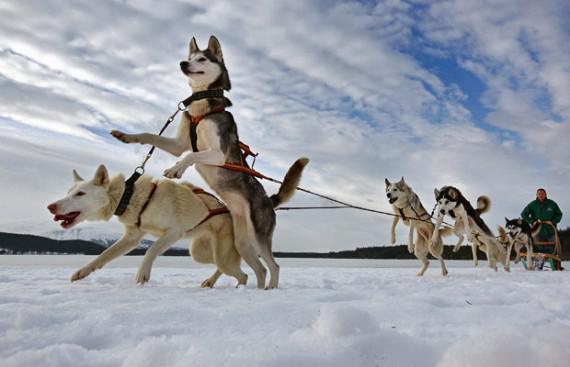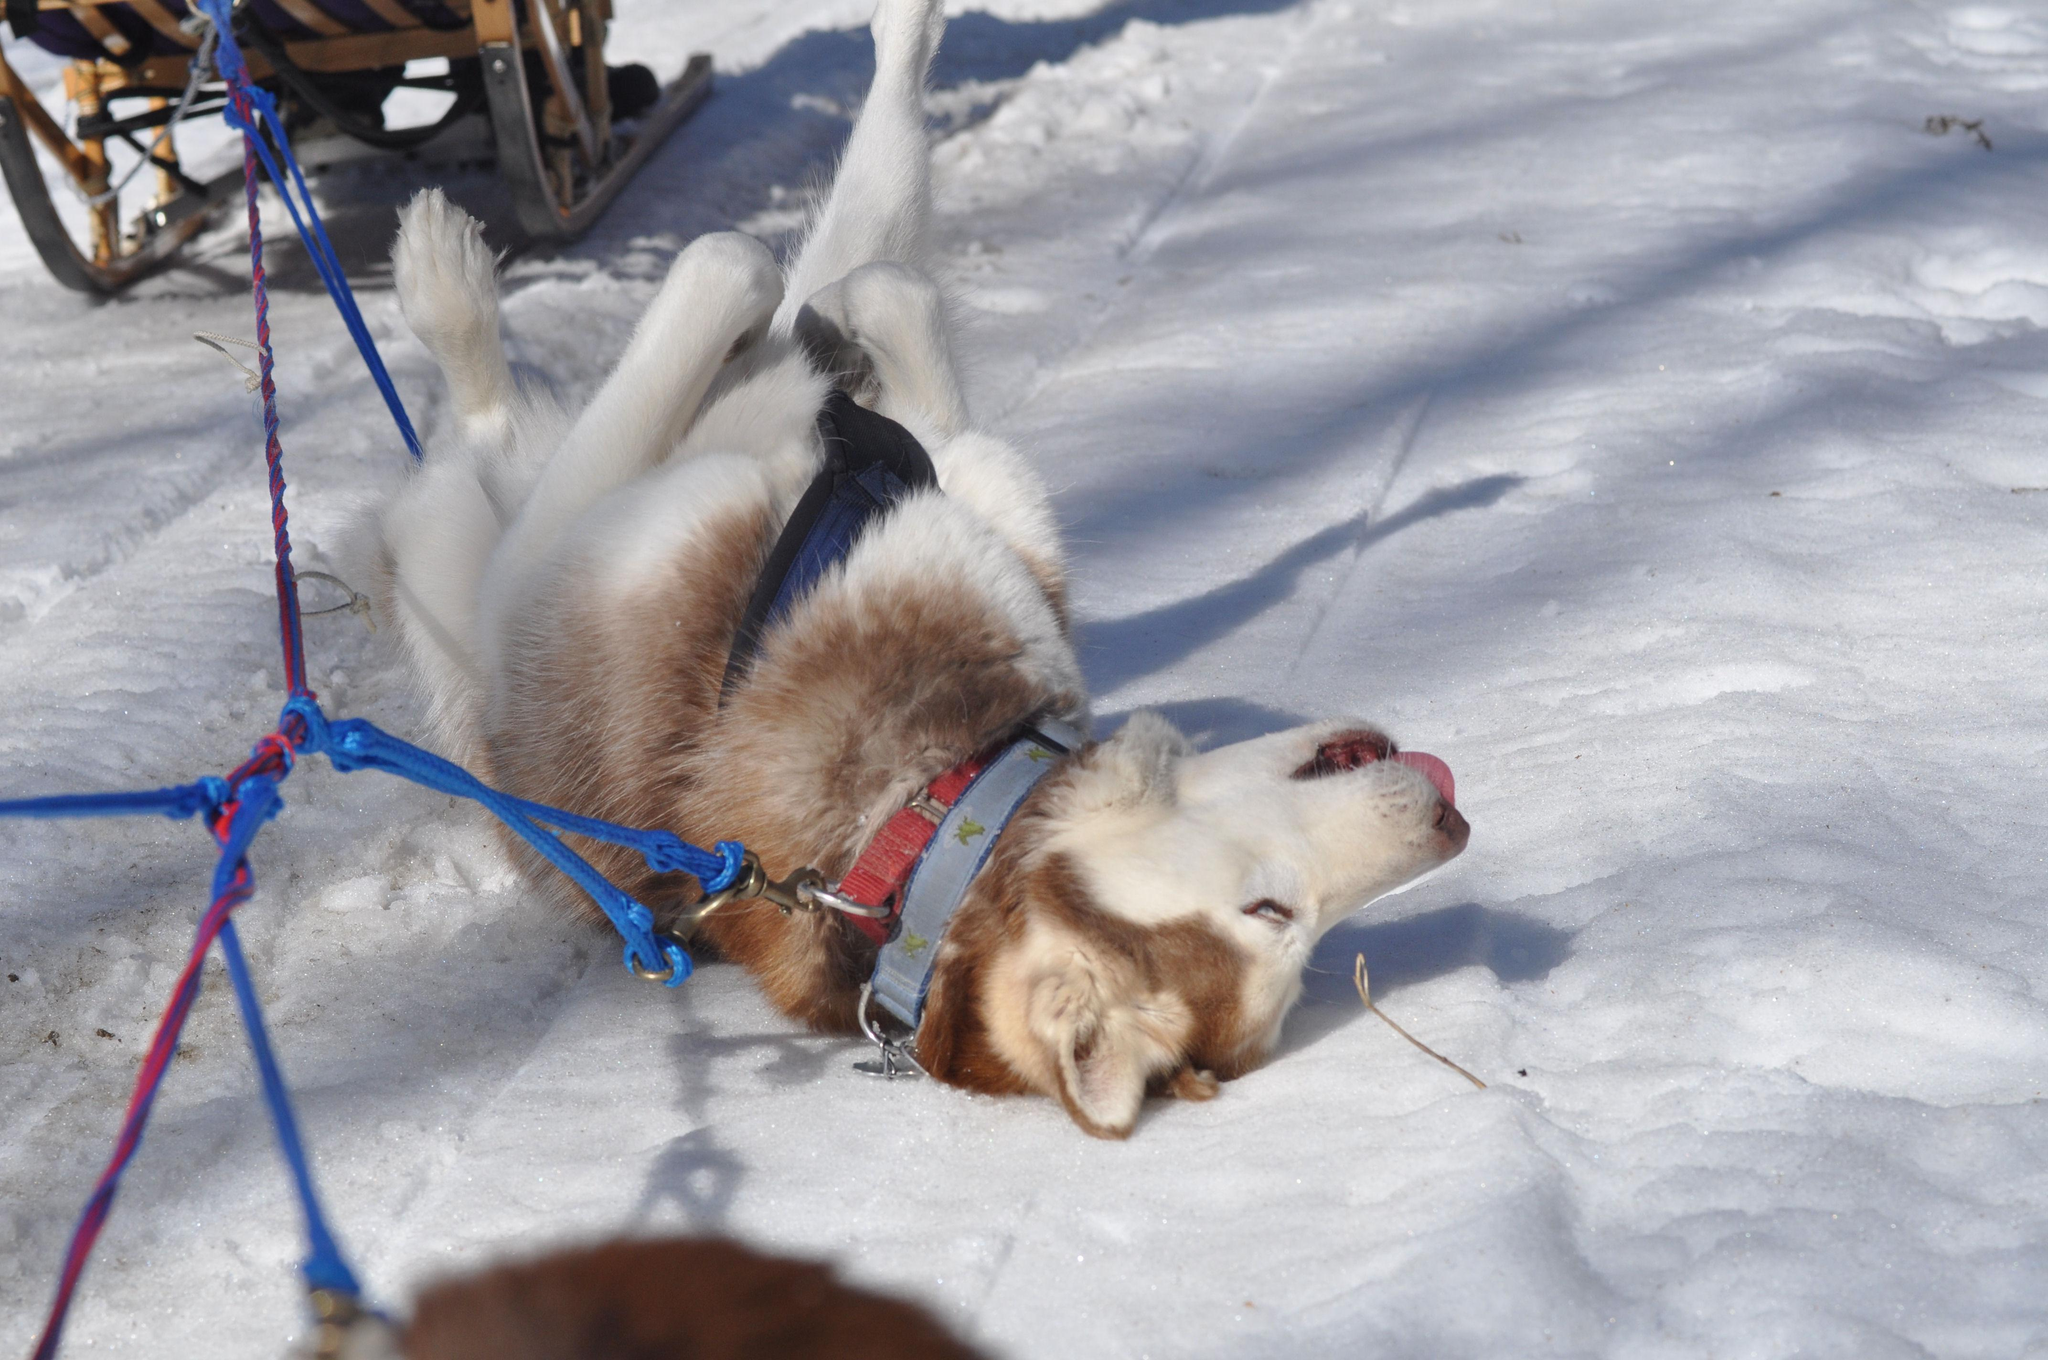The first image is the image on the left, the second image is the image on the right. Given the left and right images, does the statement "There is snow on the trees in one of the images." hold true? Answer yes or no. No. 